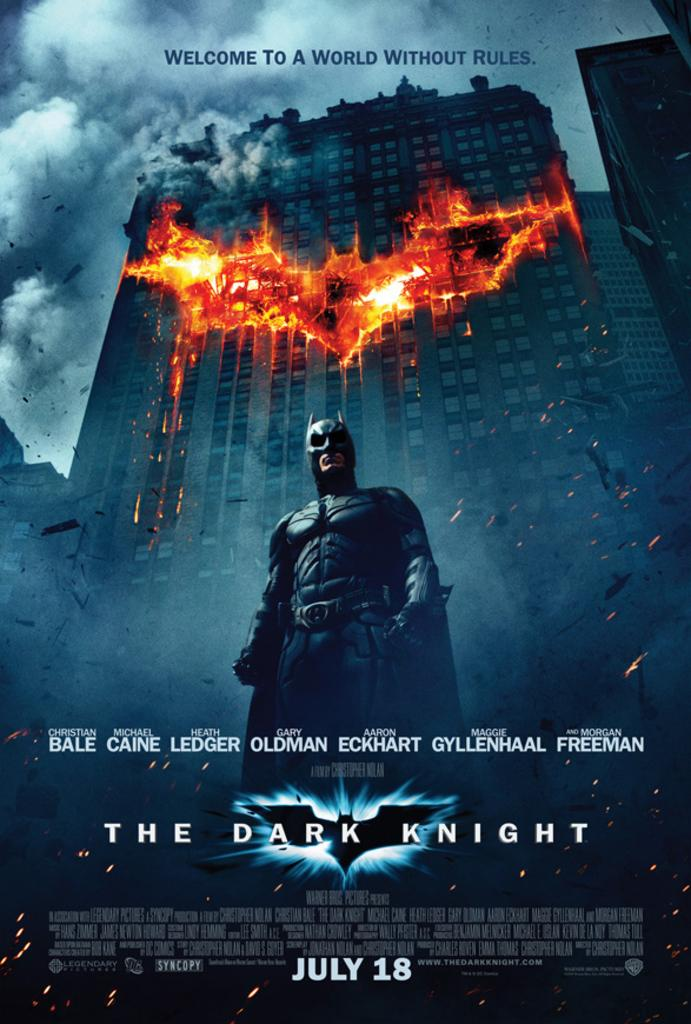<image>
Render a clear and concise summary of the photo. Superhero poster which comes out on July 18th. 